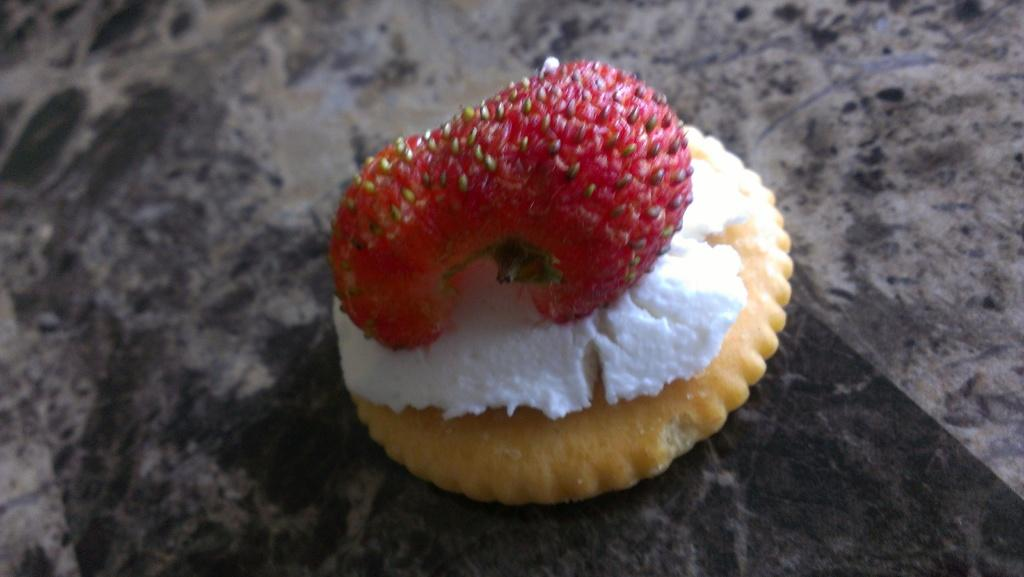What is the main subject of the image? The main subject of the image is a biscuit. What is on top of the biscuit? There is cream in white color on the biscuit, and a strawberry in red color on top of the cream. What type of muscle can be seen flexing in the image? There is no muscle visible in the image; it features a biscuit with cream and a strawberry on top. 